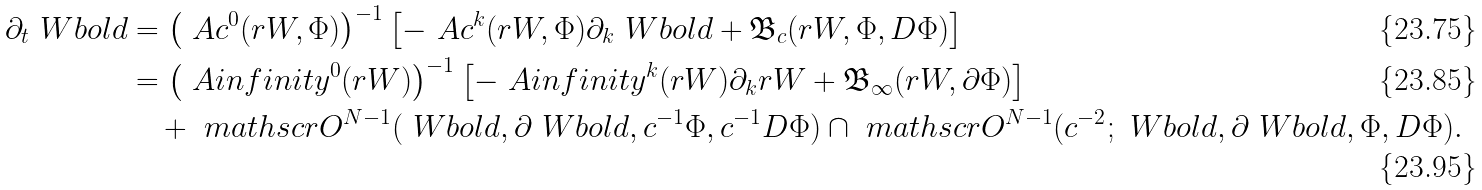Convert formula to latex. <formula><loc_0><loc_0><loc_500><loc_500>\partial _ { t } \ W b o l d & = \left ( \ A c ^ { 0 } ( r W , \Phi ) \right ) ^ { - 1 } \left [ - \ A c ^ { k } ( r W , \Phi ) \partial _ { k } \ W b o l d + \mathfrak { B } _ { c } ( r W , \Phi , D \Phi ) \right ] \\ & = \left ( \ A i n f i n i t y ^ { 0 } ( r W ) \right ) ^ { - 1 } \left [ - \ A i n f i n i t y ^ { k } ( r W ) \partial _ { k } r W + \mathfrak { B } _ { \infty } ( r W , \partial \Phi ) \right ] \\ & \quad + \ m a t h s c r { O } ^ { N - 1 } ( \ W b o l d , \partial \ W b o l d , c ^ { - 1 } \Phi , c ^ { - 1 } D \Phi ) \cap \ m a t h s c r { O } ^ { N - 1 } ( c ^ { - 2 } ; \ W b o l d , \partial \ W b o l d , \Phi , D \Phi ) .</formula> 